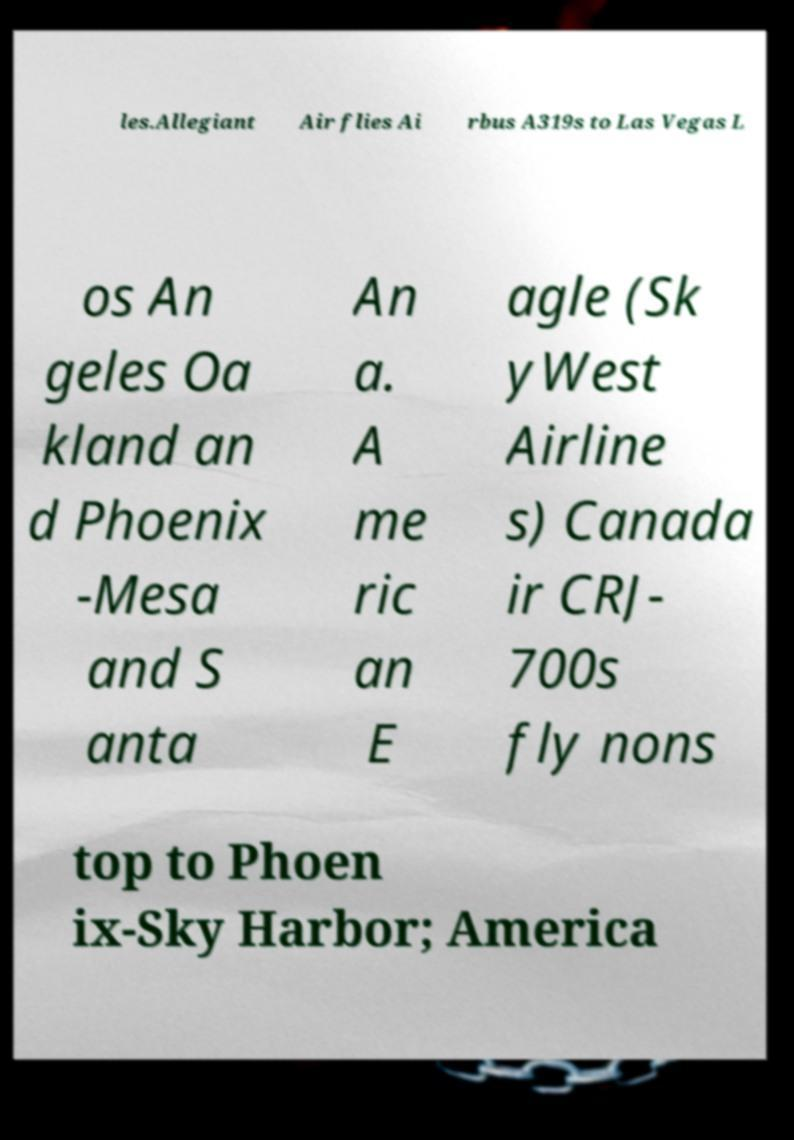I need the written content from this picture converted into text. Can you do that? les.Allegiant Air flies Ai rbus A319s to Las Vegas L os An geles Oa kland an d Phoenix -Mesa and S anta An a. A me ric an E agle (Sk yWest Airline s) Canada ir CRJ- 700s fly nons top to Phoen ix-Sky Harbor; America 